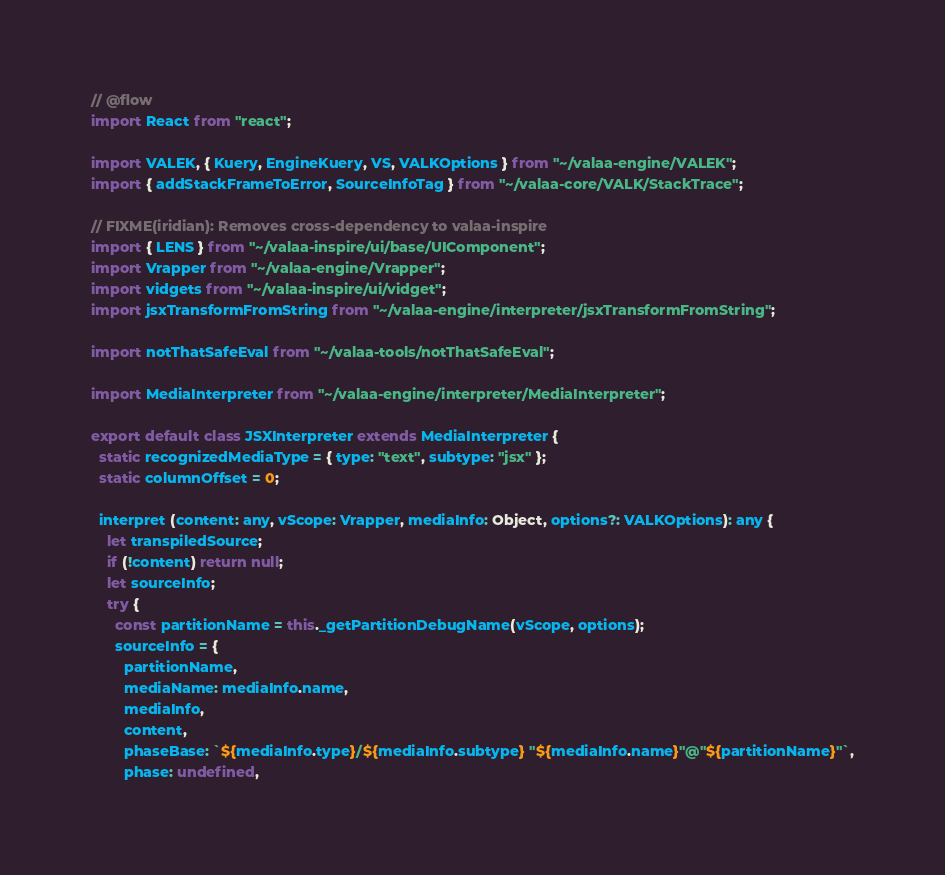<code> <loc_0><loc_0><loc_500><loc_500><_JavaScript_>// @flow
import React from "react";

import VALEK, { Kuery, EngineKuery, VS, VALKOptions } from "~/valaa-engine/VALEK";
import { addStackFrameToError, SourceInfoTag } from "~/valaa-core/VALK/StackTrace";

// FIXME(iridian): Removes cross-dependency to valaa-inspire
import { LENS } from "~/valaa-inspire/ui/base/UIComponent";
import Vrapper from "~/valaa-engine/Vrapper";
import vidgets from "~/valaa-inspire/ui/vidget";
import jsxTransformFromString from "~/valaa-engine/interpreter/jsxTransformFromString";

import notThatSafeEval from "~/valaa-tools/notThatSafeEval";

import MediaInterpreter from "~/valaa-engine/interpreter/MediaInterpreter";

export default class JSXInterpreter extends MediaInterpreter {
  static recognizedMediaType = { type: "text", subtype: "jsx" };
  static columnOffset = 0;

  interpret (content: any, vScope: Vrapper, mediaInfo: Object, options?: VALKOptions): any {
    let transpiledSource;
    if (!content) return null;
    let sourceInfo;
    try {
      const partitionName = this._getPartitionDebugName(vScope, options);
      sourceInfo = {
        partitionName,
        mediaName: mediaInfo.name,
        mediaInfo,
        content,
        phaseBase: `${mediaInfo.type}/${mediaInfo.subtype} "${mediaInfo.name}"@"${partitionName}"`,
        phase: undefined,</code> 